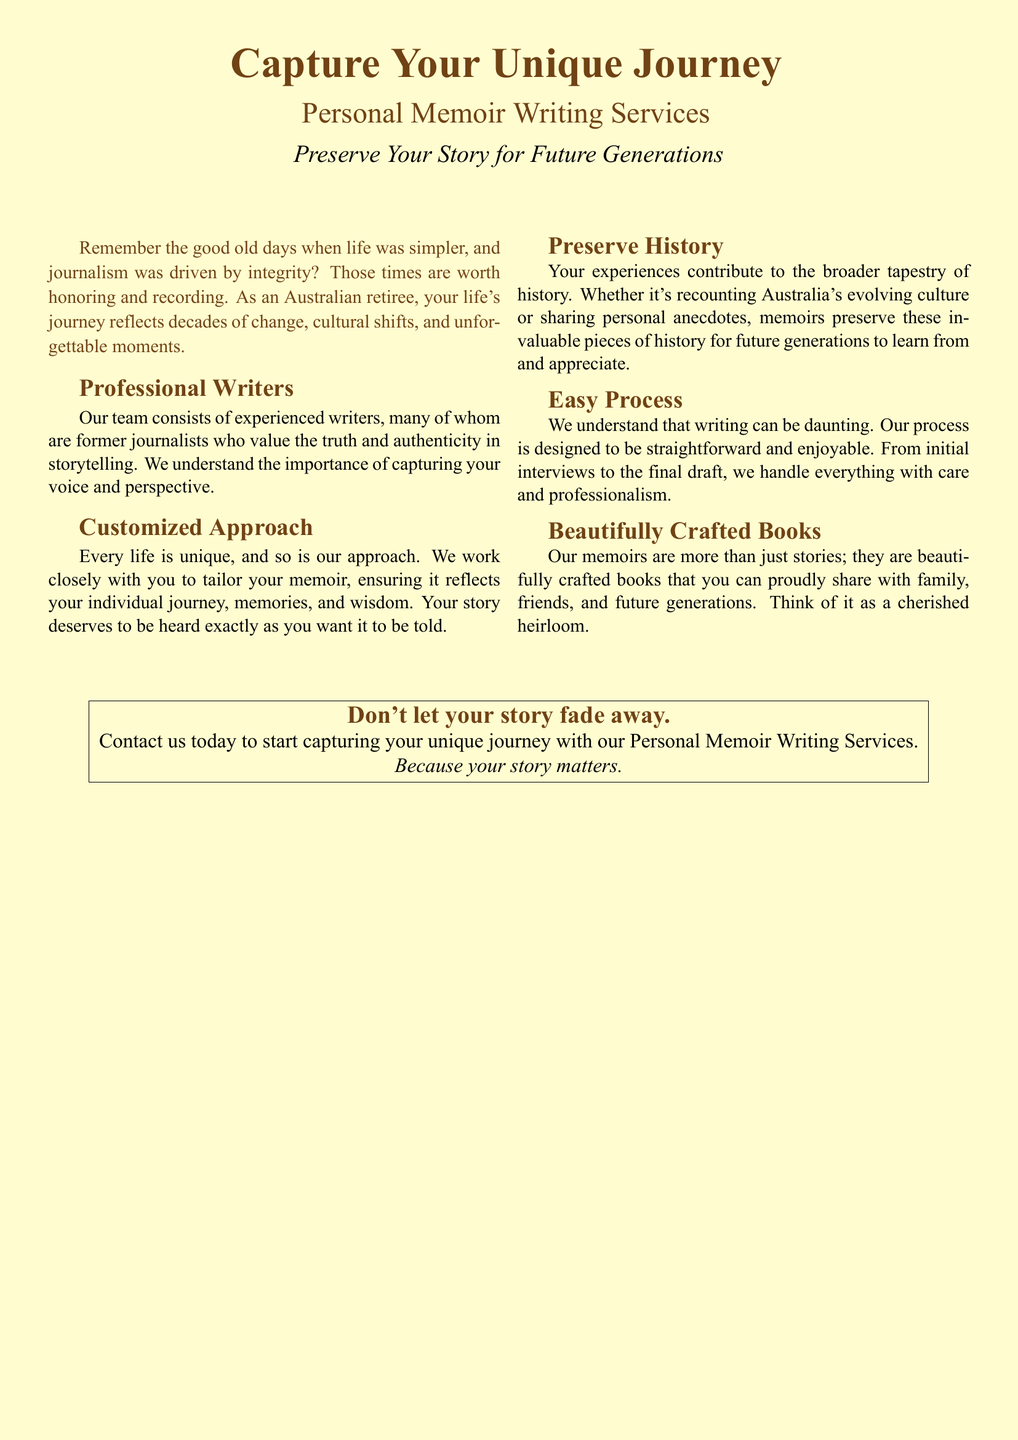What is the title of the service? The title of the service is displayed prominently at the top of the document.
Answer: Capture Your Unique Journey What is the main focus of the personal memoir writing service? The main focus is to preserve individual stories and experiences for future generations.
Answer: Preserve Your Story for Future Generations Who comprises the writing team? The document states the composition of the team in the section about professional writers.
Answer: Experienced writers, former journalists What is the document's intended audience? The intended audience is indicated in the text that addresses Australian retirees.
Answer: Australian retirees What is the emphasized quality of the memoirs created? The qualities of the memoirs are highlighted in the section on beautifully crafted books.
Answer: Beautifully crafted books How is the writing process described? The document provides insight into the nature of the writing process within its content.
Answer: Straightforward and enjoyable What can memoirs help preserve? The document outlines what memoirs contribute to in a historical context.
Answer: History What final message does the document convey? The final message is conveyed through a closing statement urging action.
Answer: Your story matters 